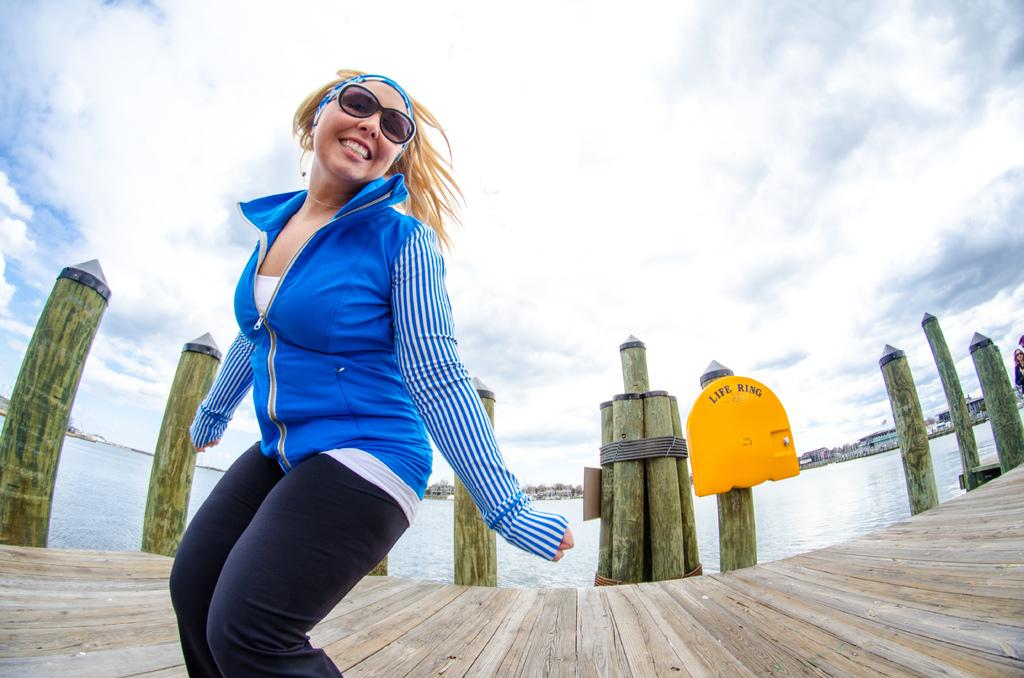Who is present in the image? There is a lady in the image. What type of structure can be seen at the bottom of the image? There is a board bridge at the bottom of the image. What can be seen in the background of the image? Water, buildings, and the sky are visible in the background of the image. What type of collar can be seen on the moon in the image? There is no moon present in the image, and therefore no collar can be seen on it. Is there a baseball game taking place in the image? There is no indication of a baseball game or any sports activity in the image. 